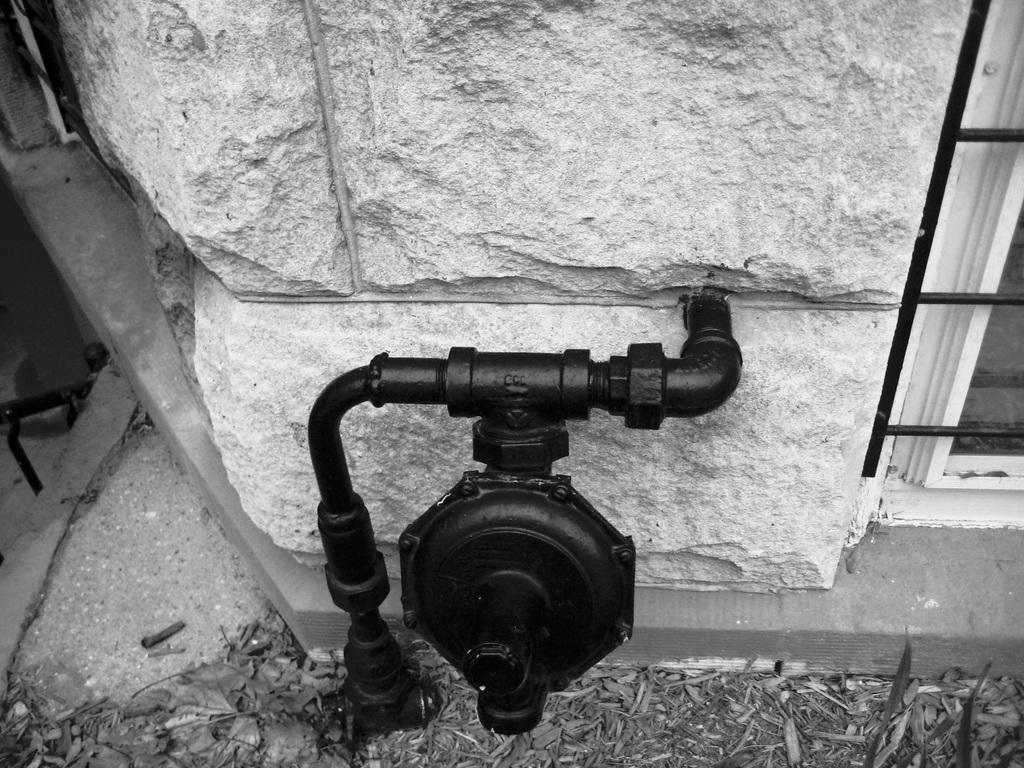What is the color scheme of the image? The image is black and white. What object can be seen in the image that is attached to a wall? There is a pipe in the image that is attached to a wall. What architectural feature is visible in the image? There is a window in the image. What type of natural debris can be seen on the ground in the image? Dried leaves are present on the ground in the image. Can you tell me how many doors are visible in the image? There are no doors visible in the image; only a pipe, a window, and dried leaves on the ground are present. What color is the eye of the person in the image? There is no person or eye present in the image; it is a black and white image featuring a pipe, a window, and dried leaves on the ground. 